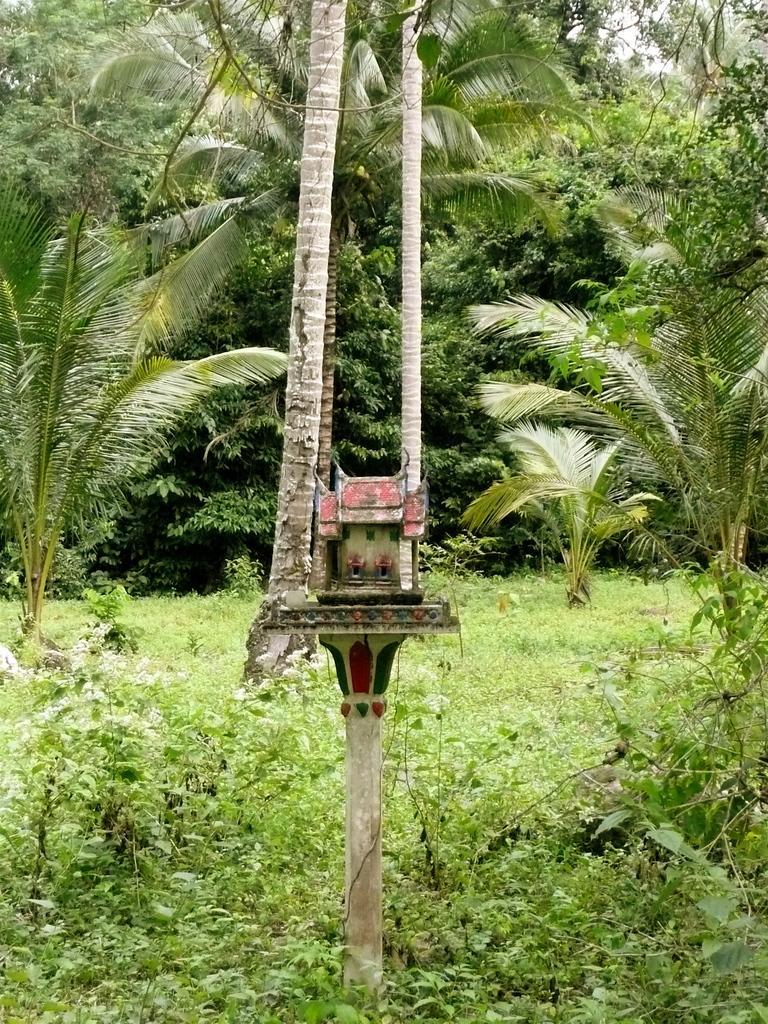Please provide a concise description of this image. In the foreground of the image we can see the small plants. In the middle of the image we can see trees and an object which looks like a small house. On the top of the image we can see trees. 